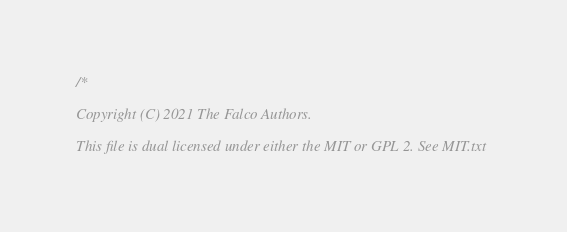Convert code to text. <code><loc_0><loc_0><loc_500><loc_500><_C_>/*

Copyright (C) 2021 The Falco Authors.

This file is dual licensed under either the MIT or GPL 2. See MIT.txt</code> 